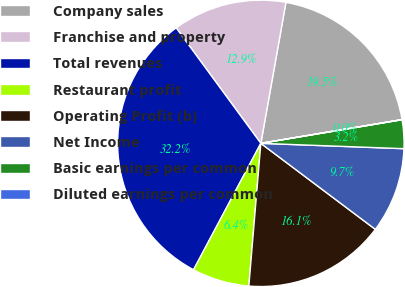Convert chart to OTSL. <chart><loc_0><loc_0><loc_500><loc_500><pie_chart><fcel>Company sales<fcel>Franchise and property<fcel>Total revenues<fcel>Restaurant profit<fcel>Operating Profit (b)<fcel>Net Income<fcel>Basic earnings per common<fcel>Diluted earnings per common<nl><fcel>19.54%<fcel>12.87%<fcel>32.15%<fcel>6.45%<fcel>16.08%<fcel>9.66%<fcel>3.23%<fcel>0.02%<nl></chart> 